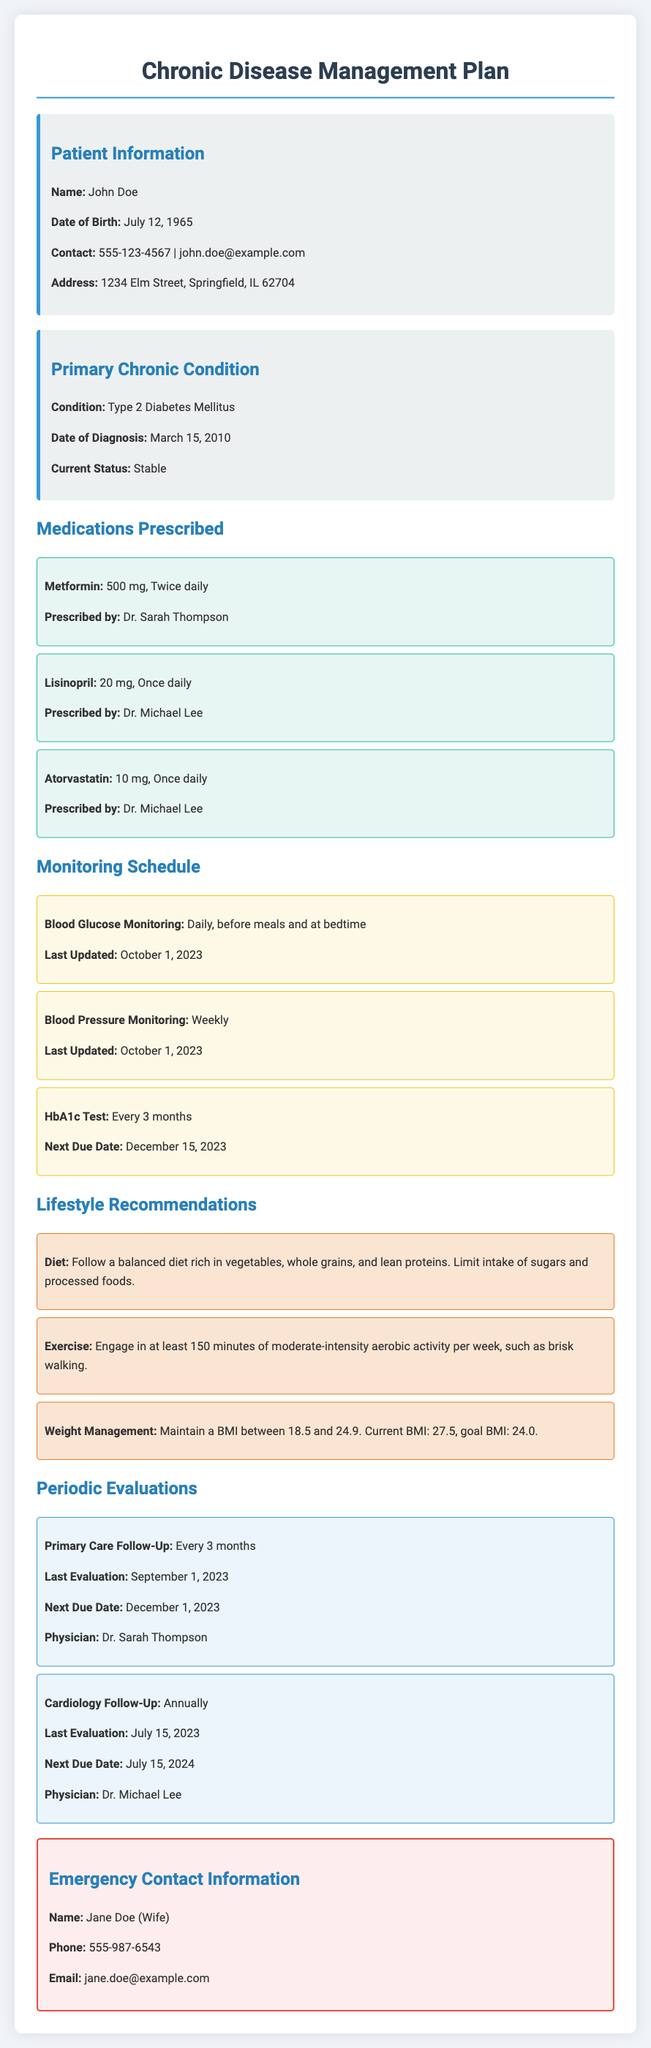What is the patient's name? The patient's name is provided in the Patient Information section.
Answer: John Doe What medication is prescribed for blood pressure? The section on Medications Prescribed lists Lisinopril specifically for this purpose.
Answer: Lisinopril What is the date of the last HbA1c test? The document states that the next test is due on December 15, 2023, suggesting that the last one was approximately three months prior.
Answer: September 15, 2023 How often should the patient follow up with their primary care physician? This information is found in the Periodic Evaluations section under Primary Care Follow-Up.
Answer: Every 3 months What is the patient's current BMI? The document provides the current BMI in the Lifestyle Recommendations section.
Answer: 27.5 What lifestyle recommendation involves food intake? The Lifestyle Recommendations section discusses various aspects of diet for the patient.
Answer: Follow a balanced diet rich in vegetables, whole grains, and lean proteins Who is the physician for cardiology follow-up? The evaluation details in the Periodic Evaluations section mention the physician's name.
Answer: Dr. Michael Lee What is the next due date for the cardiology follow-up? This date is specified in the Periodic Evaluations section under Cardiology Follow-Up.
Answer: July 15, 2024 Which chronic condition does the patient have? The information can be found in the Primary Chronic Condition section of the document.
Answer: Type 2 Diabetes Mellitus 